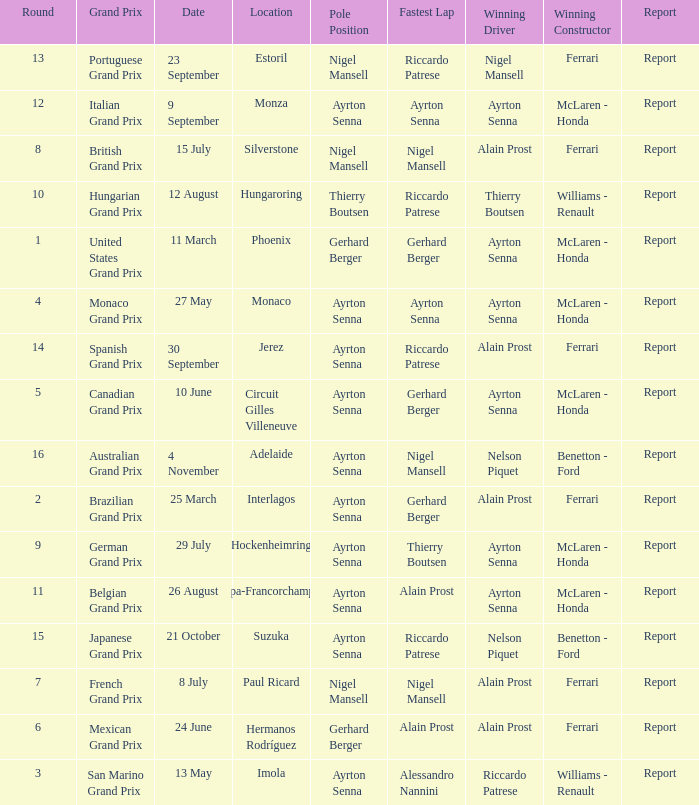What was the constructor when riccardo patrese was the winning driver? Williams - Renault. 